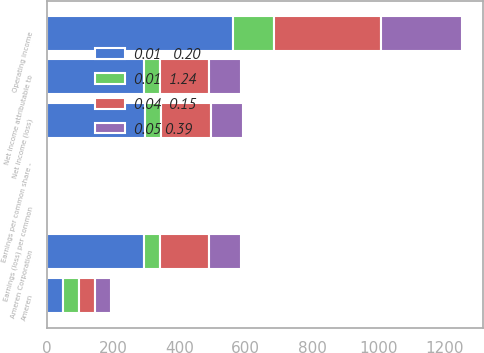<chart> <loc_0><loc_0><loc_500><loc_500><stacked_bar_chart><ecel><fcel>Ameren<fcel>Operating income<fcel>Net income (loss)<fcel>Net income attributable to<fcel>Ameren Corporation<fcel>Earnings per common share -<fcel>Earnings (loss) per common<nl><fcel>0.05 0.39<fcel>48.5<fcel>246<fcel>98<fcel>97<fcel>96<fcel>0.4<fcel>0.4<nl><fcel>0.04  0.15<fcel>48.5<fcel>322<fcel>150<fcel>150<fcel>149<fcel>0.62<fcel>0.61<nl><fcel>0.01   0.20<fcel>48.5<fcel>561<fcel>295<fcel>294<fcel>293<fcel>1.2<fcel>1.21<nl><fcel>0.01  1.24<fcel>48.5<fcel>125<fcel>49<fcel>46<fcel>48<fcel>0.19<fcel>0.2<nl></chart> 